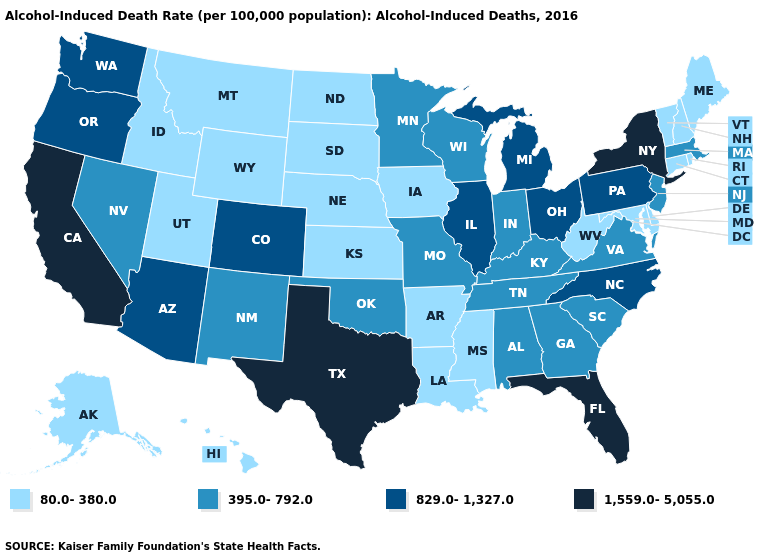What is the highest value in the USA?
Be succinct. 1,559.0-5,055.0. Which states have the lowest value in the MidWest?
Quick response, please. Iowa, Kansas, Nebraska, North Dakota, South Dakota. Among the states that border Ohio , which have the highest value?
Quick response, please. Michigan, Pennsylvania. Which states hav the highest value in the MidWest?
Concise answer only. Illinois, Michigan, Ohio. Name the states that have a value in the range 1,559.0-5,055.0?
Short answer required. California, Florida, New York, Texas. Which states have the lowest value in the West?
Short answer required. Alaska, Hawaii, Idaho, Montana, Utah, Wyoming. What is the value of Louisiana?
Quick response, please. 80.0-380.0. Does Rhode Island have the lowest value in the USA?
Concise answer only. Yes. Which states have the lowest value in the MidWest?
Be succinct. Iowa, Kansas, Nebraska, North Dakota, South Dakota. What is the lowest value in states that border Ohio?
Short answer required. 80.0-380.0. Which states have the lowest value in the USA?
Quick response, please. Alaska, Arkansas, Connecticut, Delaware, Hawaii, Idaho, Iowa, Kansas, Louisiana, Maine, Maryland, Mississippi, Montana, Nebraska, New Hampshire, North Dakota, Rhode Island, South Dakota, Utah, Vermont, West Virginia, Wyoming. What is the value of Delaware?
Keep it brief. 80.0-380.0. Which states have the highest value in the USA?
Short answer required. California, Florida, New York, Texas. Does New York have the highest value in the Northeast?
Write a very short answer. Yes. 